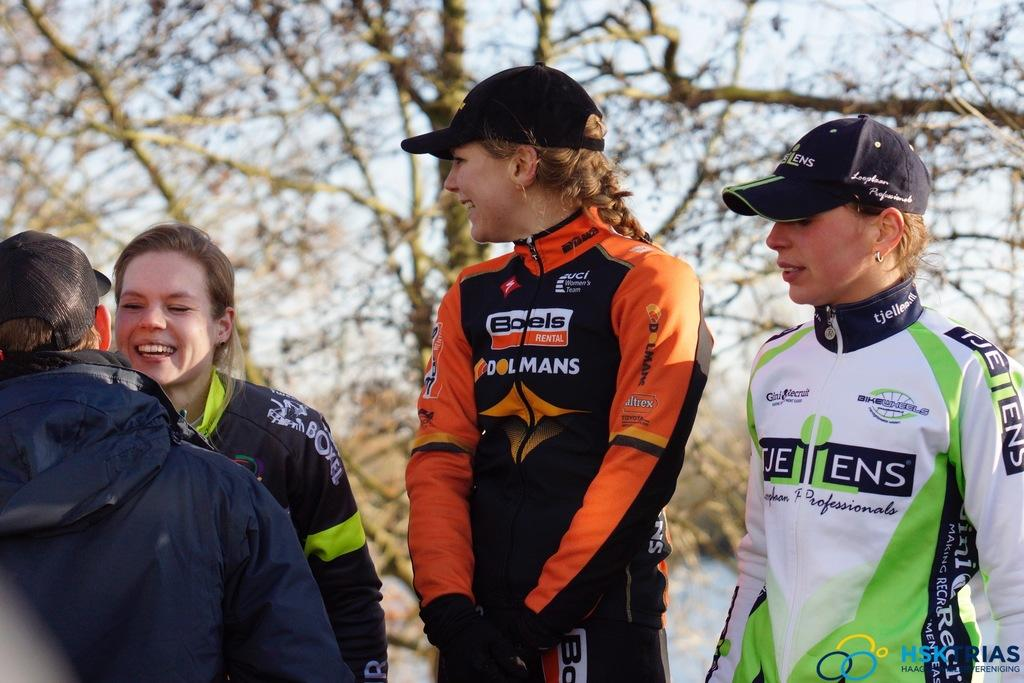Provide a one-sentence caption for the provided image. A girl with a race suit sponsored by Boels stands among other women in racing suits. 